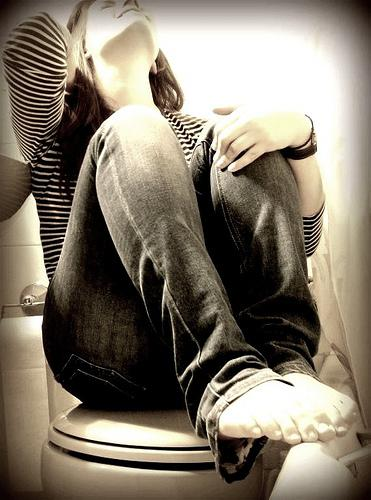Question: what are her pants like?
Choices:
A. Cargo pants.
B. Khakis.
C. Slacks.
D. Jeans.
Answer with the letter. Answer: D Question: what is she sitting on?
Choices:
A. Chair.
B. Bench.
C. Bed.
D. Toilet.
Answer with the letter. Answer: D Question: where is she?
Choices:
A. Bathroom.
B. Bedroom.
C. Kitchen.
D. Attic.
Answer with the letter. Answer: A Question: what is on her feet?
Choices:
A. Shoes.
B. Boots.
C. Nothing.
D. Sandals.
Answer with the letter. Answer: C Question: how is her expression?
Choices:
A. Angry.
B. Amused.
C. Upset.
D. Concerned.
Answer with the letter. Answer: B Question: when will she leave?
Choices:
A. Tomorrow.
B. Next week.
C. Soon.
D. Tonight.
Answer with the letter. Answer: C Question: who is there?
Choices:
A. Boy.
B. Girl.
C. Man.
D. Woman.
Answer with the letter. Answer: B 